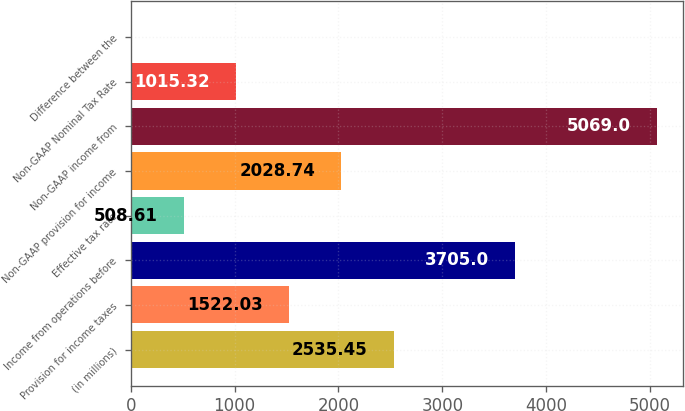Convert chart to OTSL. <chart><loc_0><loc_0><loc_500><loc_500><bar_chart><fcel>(in millions)<fcel>Provision for income taxes<fcel>Income from operations before<fcel>Effective tax rate<fcel>Non-GAAP provision for income<fcel>Non-GAAP income from<fcel>Non-GAAP Nominal Tax Rate<fcel>Difference between the<nl><fcel>2535.45<fcel>1522.03<fcel>3705<fcel>508.61<fcel>2028.74<fcel>5069<fcel>1015.32<fcel>1.9<nl></chart> 